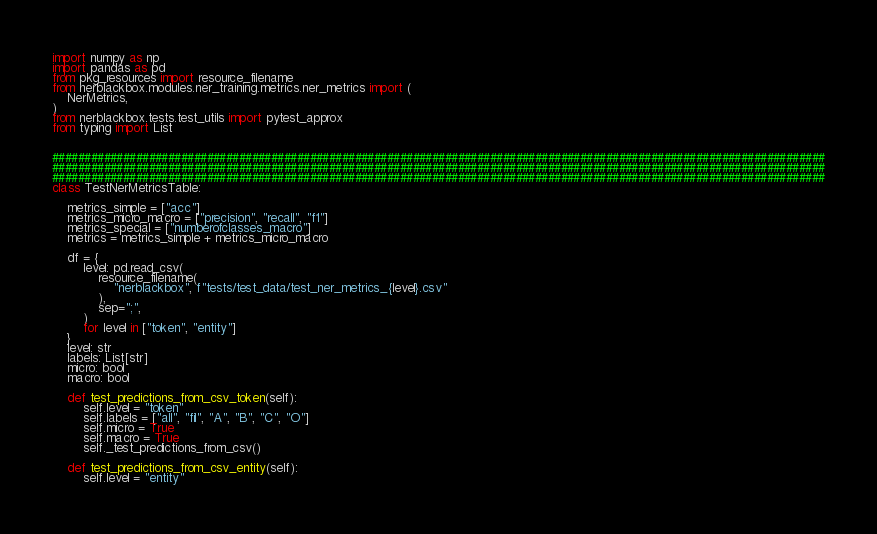<code> <loc_0><loc_0><loc_500><loc_500><_Python_>import numpy as np
import pandas as pd
from pkg_resources import resource_filename
from nerblackbox.modules.ner_training.metrics.ner_metrics import (
    NerMetrics,
)
from nerblackbox.tests.test_utils import pytest_approx
from typing import List


########################################################################################################################
########################################################################################################################
########################################################################################################################
class TestNerMetricsTable:

    metrics_simple = ["acc"]
    metrics_micro_macro = ["precision", "recall", "f1"]
    metrics_special = ["numberofclasses_macro"]
    metrics = metrics_simple + metrics_micro_macro

    df = {
        level: pd.read_csv(
            resource_filename(
                "nerblackbox", f"tests/test_data/test_ner_metrics_{level}.csv"
            ),
            sep=";",
        )
        for level in ["token", "entity"]
    }
    level: str
    labels: List[str]
    micro: bool
    macro: bool

    def test_predictions_from_csv_token(self):
        self.level = "token"
        self.labels = ["all", "fil", "A", "B", "C", "O"]
        self.micro = True
        self.macro = True
        self._test_predictions_from_csv()

    def test_predictions_from_csv_entity(self):
        self.level = "entity"</code> 